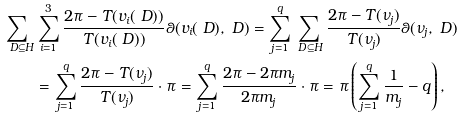<formula> <loc_0><loc_0><loc_500><loc_500>\sum _ { \ D \subseteq H } & \sum _ { i = 1 } ^ { 3 } \frac { 2 \pi - T ( v _ { i } ( \ D ) ) } { T ( v _ { i } ( \ D ) ) } \theta ( v _ { i } ( \ D ) , \ D ) = \sum _ { j = 1 } ^ { q } \sum _ { \ D \subseteq H } \frac { 2 \pi - T ( \nu _ { j } ) } { T ( \nu _ { j } ) } \theta ( \nu _ { j } , \ D ) \\ & = \sum _ { j = 1 } ^ { q } \frac { 2 \pi - T ( \nu _ { j } ) } { T ( \nu _ { j } ) } \cdot \pi = \sum _ { j = 1 } ^ { q } \frac { 2 \pi - 2 \pi m _ { j } } { 2 \pi m _ { j } } \cdot \pi = \pi \left ( \sum _ { j = 1 } ^ { q } \frac { 1 } { m _ { j } } - q \right ) ,</formula> 